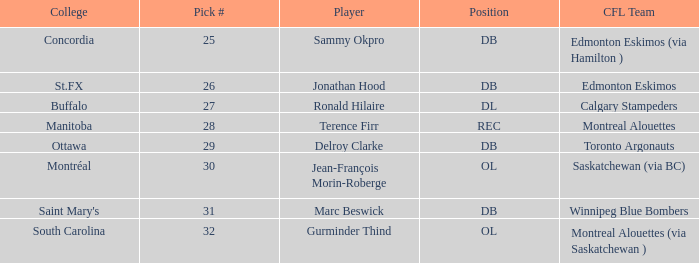What is buffalo's pick #? 27.0. I'm looking to parse the entire table for insights. Could you assist me with that? {'header': ['College', 'Pick #', 'Player', 'Position', 'CFL Team'], 'rows': [['Concordia', '25', 'Sammy Okpro', 'DB', 'Edmonton Eskimos (via Hamilton )'], ['St.FX', '26', 'Jonathan Hood', 'DB', 'Edmonton Eskimos'], ['Buffalo', '27', 'Ronald Hilaire', 'DL', 'Calgary Stampeders'], ['Manitoba', '28', 'Terence Firr', 'REC', 'Montreal Alouettes'], ['Ottawa', '29', 'Delroy Clarke', 'DB', 'Toronto Argonauts'], ['Montréal', '30', 'Jean-François Morin-Roberge', 'OL', 'Saskatchewan (via BC)'], ["Saint Mary's", '31', 'Marc Beswick', 'DB', 'Winnipeg Blue Bombers'], ['South Carolina', '32', 'Gurminder Thind', 'OL', 'Montreal Alouettes (via Saskatchewan )']]} 